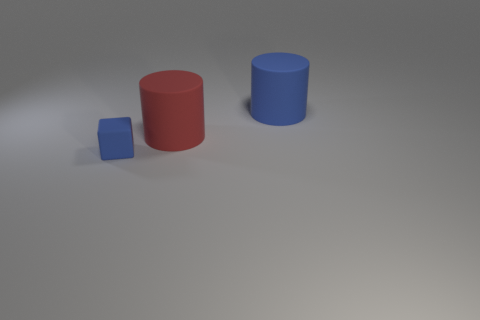Add 3 large red objects. How many objects exist? 6 Subtract 1 cylinders. How many cylinders are left? 1 Subtract all cubes. How many objects are left? 2 Subtract all big red matte things. Subtract all red matte things. How many objects are left? 1 Add 2 blue rubber cubes. How many blue rubber cubes are left? 3 Add 1 big purple metallic balls. How many big purple metallic balls exist? 1 Subtract 0 gray cubes. How many objects are left? 3 Subtract all blue cylinders. Subtract all green balls. How many cylinders are left? 1 